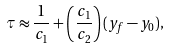<formula> <loc_0><loc_0><loc_500><loc_500>\tau \approx \frac { 1 } { c _ { 1 } } + \left ( \frac { c _ { 1 } } { c _ { 2 } } \right ) ( y _ { f } - y _ { 0 } ) ,</formula> 